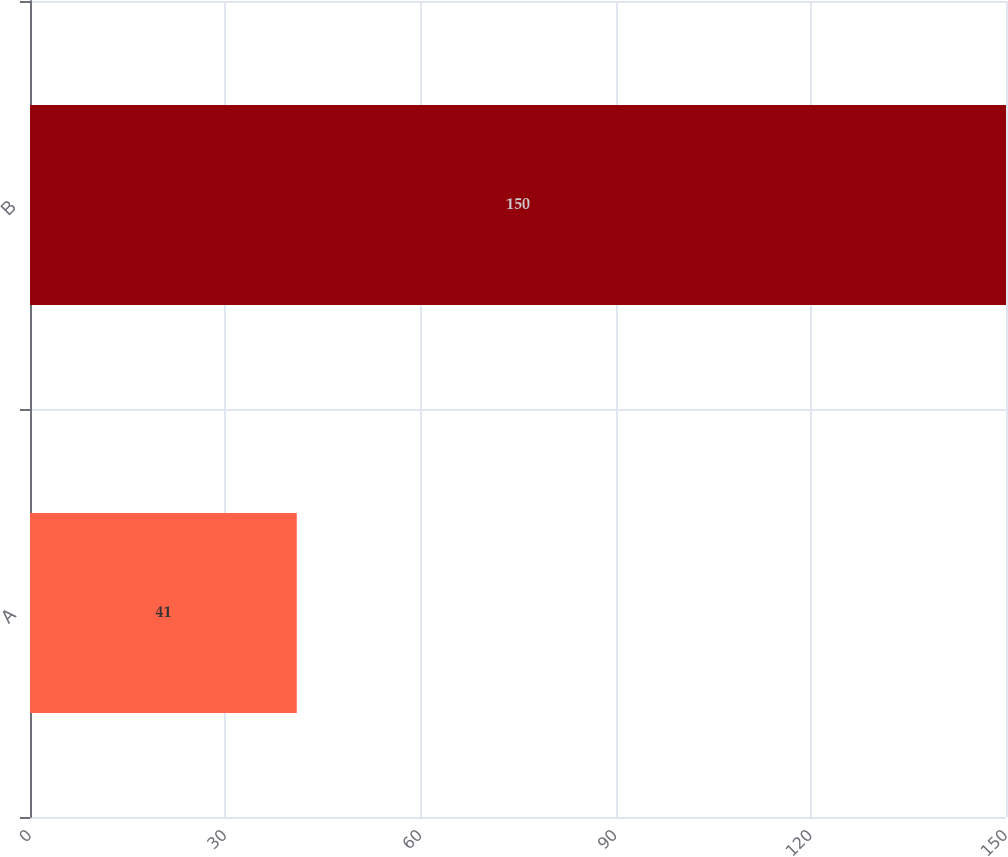Convert chart to OTSL. <chart><loc_0><loc_0><loc_500><loc_500><bar_chart><fcel>A<fcel>B<nl><fcel>41<fcel>150<nl></chart> 